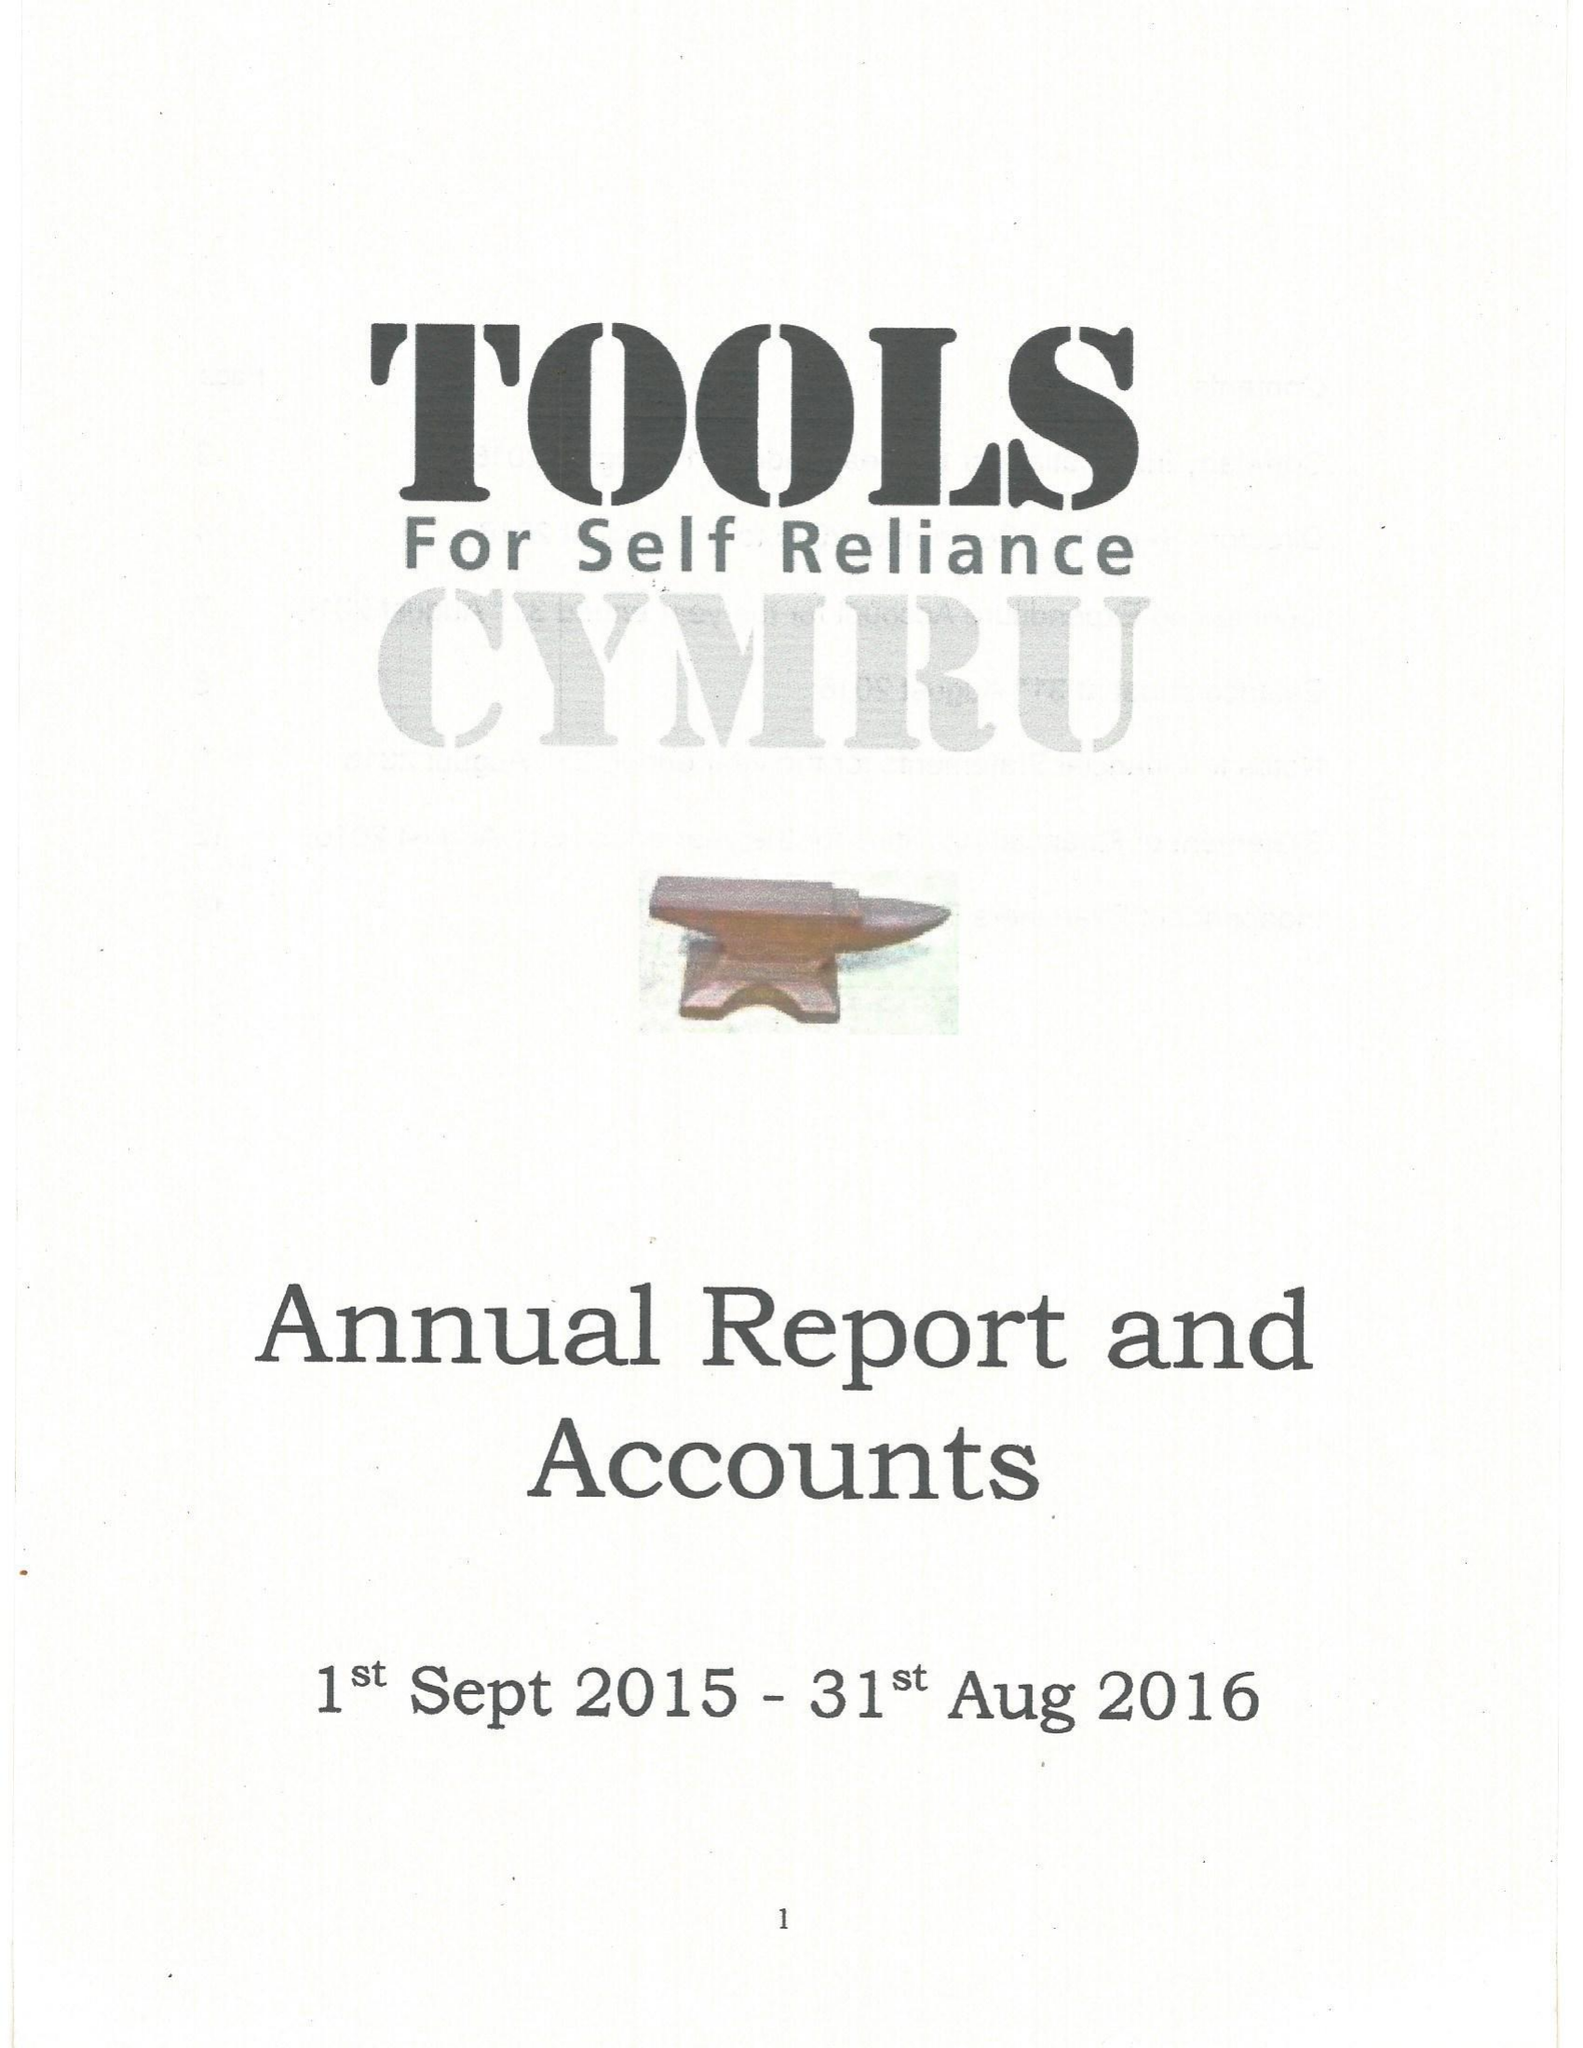What is the value for the charity_number?
Answer the question using a single word or phrase. 1055483 